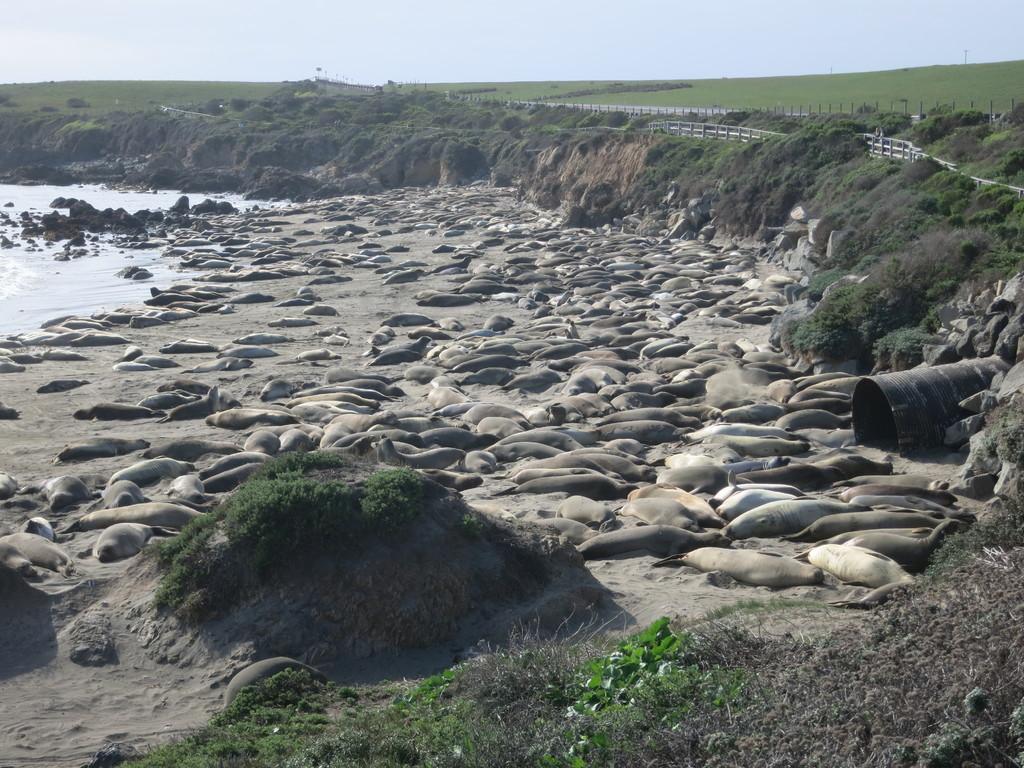Could you give a brief overview of what you see in this image? Here we can see animals are lying on the sand and on the left we can see water and stones. In the background there is grass on the ground,fences,poles and sky. On the right we can see a drum on the sand and there are small stones. At the bottom we can see small plants and grass on the ground. 